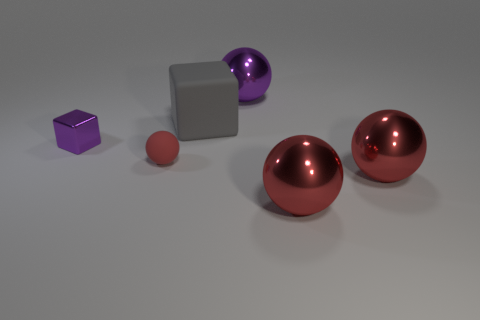Subtract all purple metallic spheres. How many spheres are left? 3 Add 1 purple objects. How many objects exist? 7 Subtract all gray cubes. How many red balls are left? 3 Subtract all balls. How many objects are left? 2 Subtract all purple spheres. How many spheres are left? 3 Subtract all red rubber objects. Subtract all purple objects. How many objects are left? 3 Add 1 small purple cubes. How many small purple cubes are left? 2 Add 2 small purple shiny cubes. How many small purple shiny cubes exist? 3 Subtract 0 yellow blocks. How many objects are left? 6 Subtract all green balls. Subtract all gray cylinders. How many balls are left? 4 